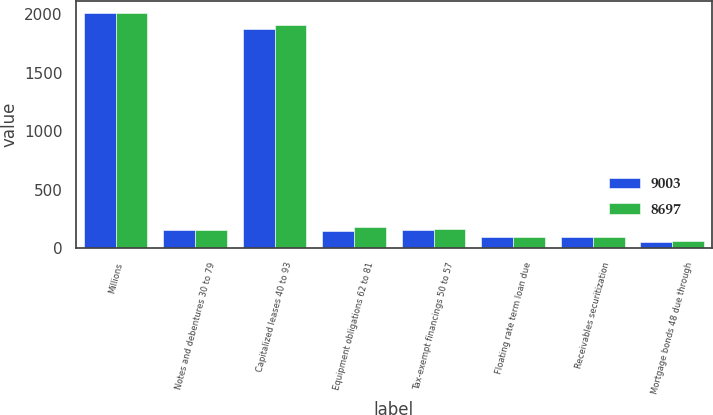<chart> <loc_0><loc_0><loc_500><loc_500><stacked_bar_chart><ecel><fcel>Millions<fcel>Notes and debentures 30 to 79<fcel>Capitalized leases 40 to 93<fcel>Equipment obligations 62 to 81<fcel>Tax-exempt financings 50 to 57<fcel>Floating rate term loan due<fcel>Receivables securitization<fcel>Mortgage bonds 48 due through<nl><fcel>9003<fcel>2011<fcel>153<fcel>1874<fcel>147<fcel>159<fcel>100<fcel>100<fcel>57<nl><fcel>8697<fcel>2010<fcel>153<fcel>1909<fcel>183<fcel>162<fcel>100<fcel>100<fcel>58<nl></chart> 